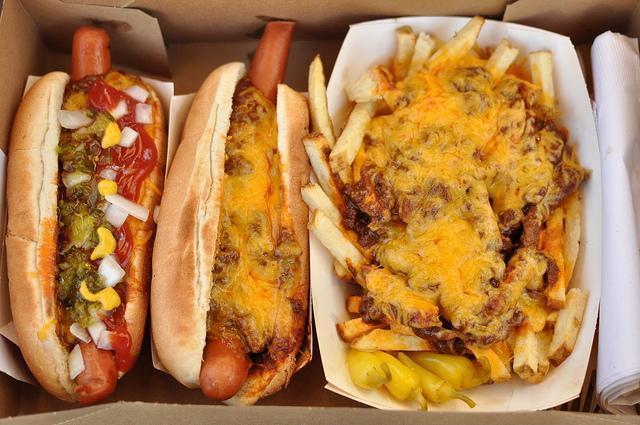How many hot dogs can you see?
Give a very brief answer. 2. How many black cups are there?
Give a very brief answer. 0. 